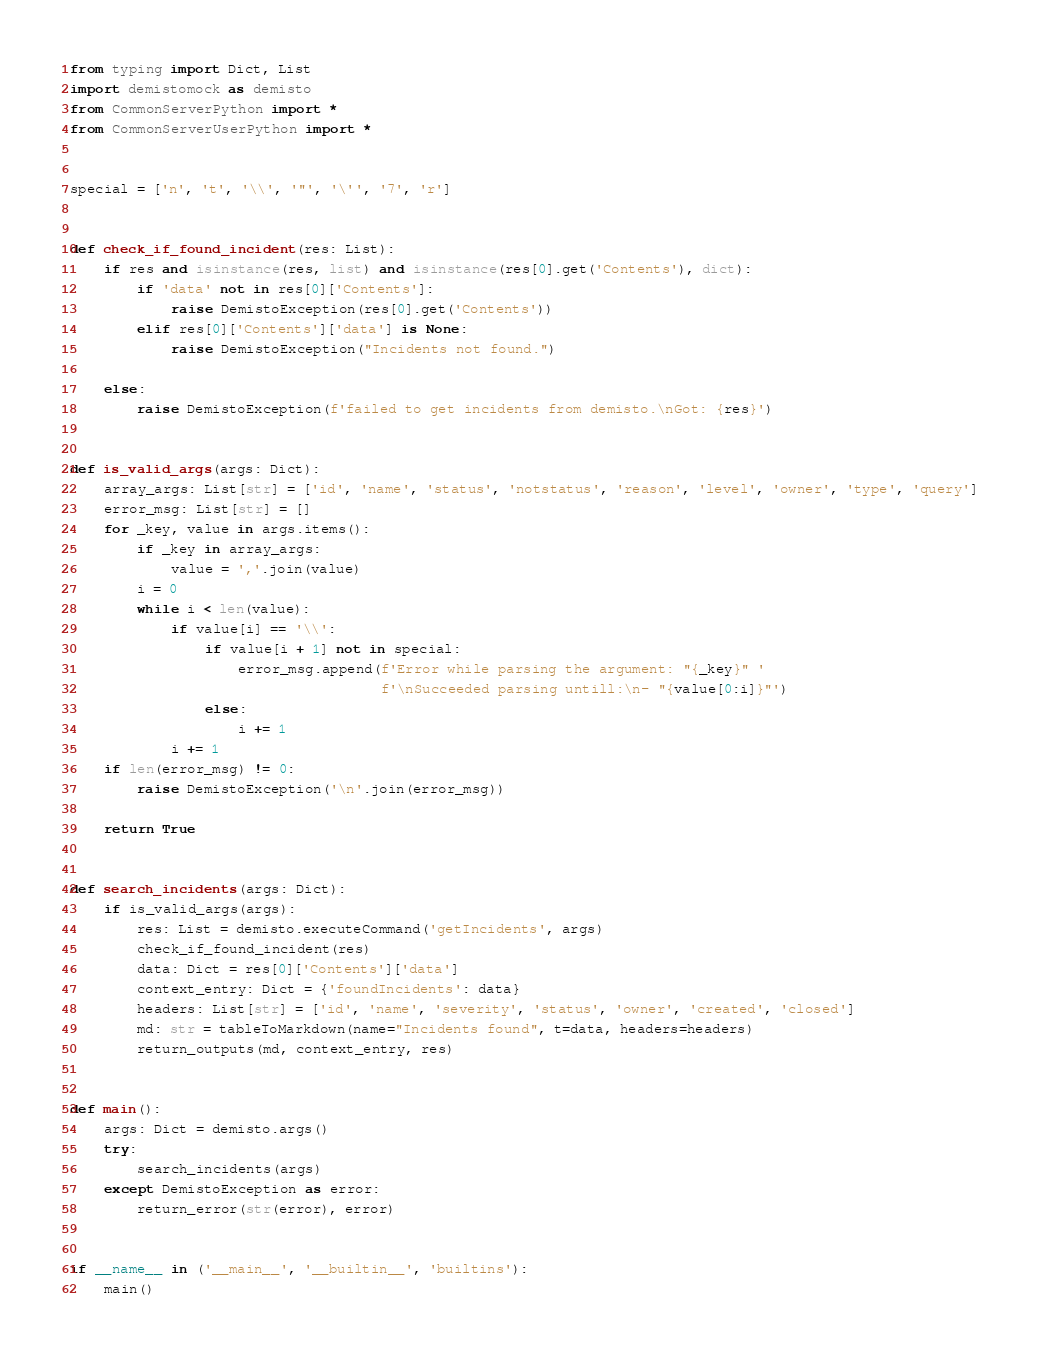Convert code to text. <code><loc_0><loc_0><loc_500><loc_500><_Python_>from typing import Dict, List
import demistomock as demisto
from CommonServerPython import *
from CommonServerUserPython import *


special = ['n', 't', '\\', '"', '\'', '7', 'r']


def check_if_found_incident(res: List):
    if res and isinstance(res, list) and isinstance(res[0].get('Contents'), dict):
        if 'data' not in res[0]['Contents']:
            raise DemistoException(res[0].get('Contents'))
        elif res[0]['Contents']['data'] is None:
            raise DemistoException("Incidents not found.")

    else:
        raise DemistoException(f'failed to get incidents from demisto.\nGot: {res}')


def is_valid_args(args: Dict):
    array_args: List[str] = ['id', 'name', 'status', 'notstatus', 'reason', 'level', 'owner', 'type', 'query']
    error_msg: List[str] = []
    for _key, value in args.items():
        if _key in array_args:
            value = ','.join(value)
        i = 0
        while i < len(value):
            if value[i] == '\\':
                if value[i + 1] not in special:
                    error_msg.append(f'Error while parsing the argument: "{_key}" '
                                     f'\nSucceeded parsing untill:\n- "{value[0:i]}"')
                else:
                    i += 1
            i += 1
    if len(error_msg) != 0:
        raise DemistoException('\n'.join(error_msg))

    return True


def search_incidents(args: Dict):
    if is_valid_args(args):
        res: List = demisto.executeCommand('getIncidents', args)
        check_if_found_incident(res)
        data: Dict = res[0]['Contents']['data']
        context_entry: Dict = {'foundIncidents': data}
        headers: List[str] = ['id', 'name', 'severity', 'status', 'owner', 'created', 'closed']
        md: str = tableToMarkdown(name="Incidents found", t=data, headers=headers)
        return_outputs(md, context_entry, res)


def main():
    args: Dict = demisto.args()
    try:
        search_incidents(args)
    except DemistoException as error:
        return_error(str(error), error)


if __name__ in ('__main__', '__builtin__', 'builtins'):
    main()
</code> 